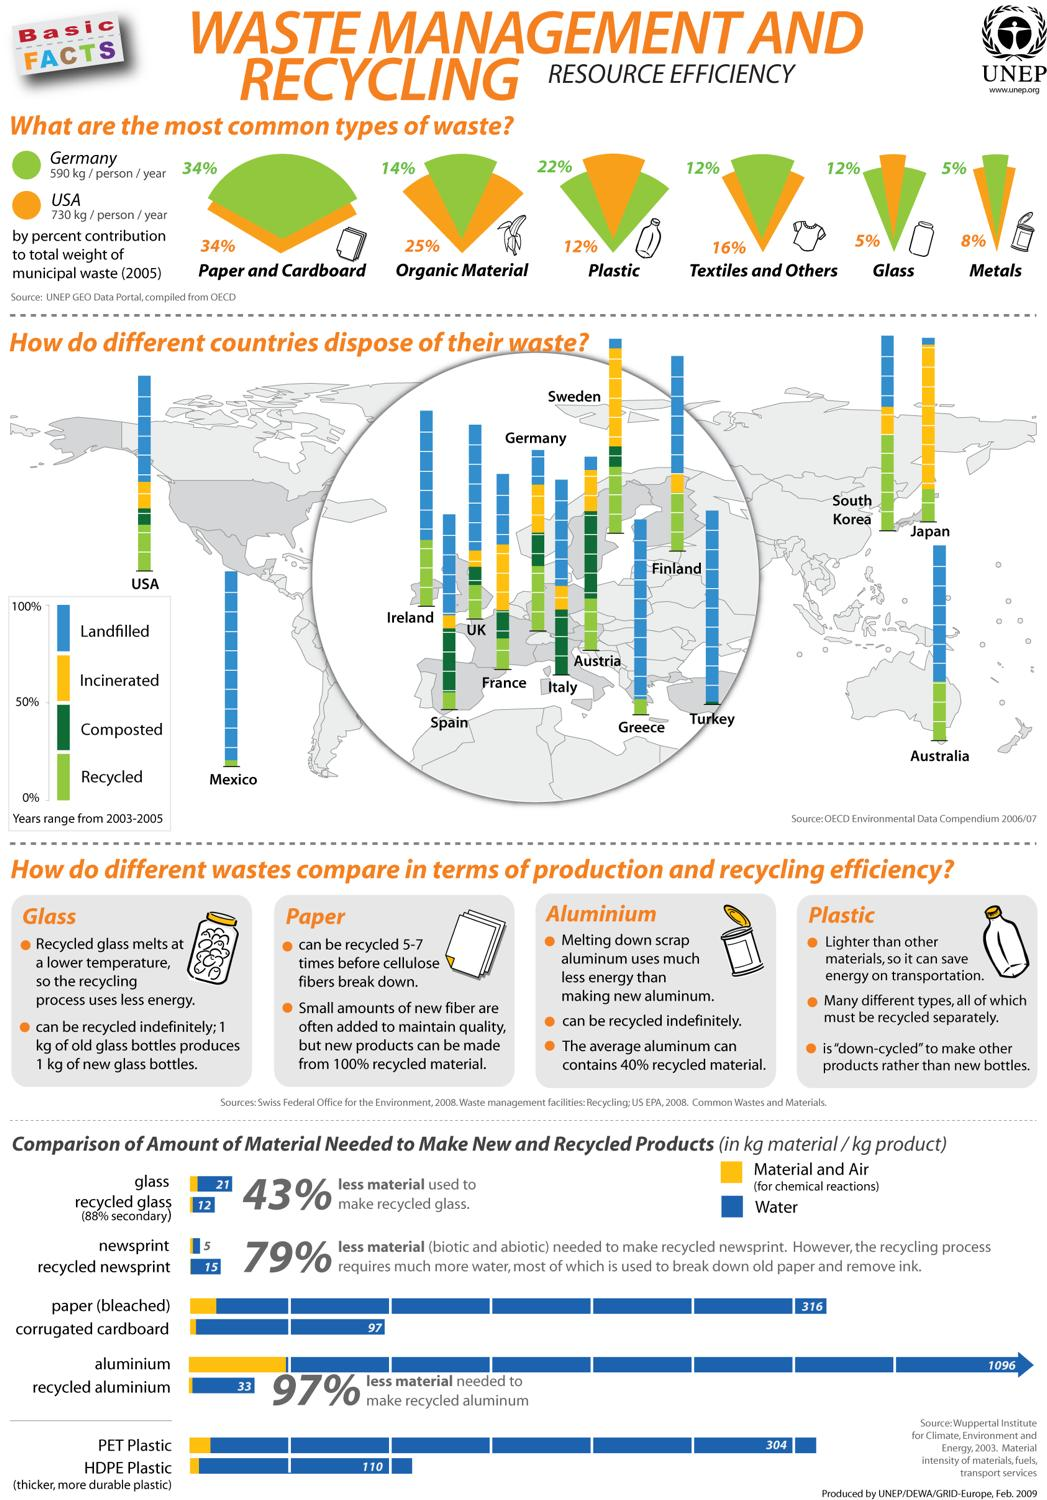Identify some key points in this picture. The United States generates more organic waste than Germany. Austria has the highest percentage of composted waste among all countries. The waste generated by the US and Germany consists of 34% paper and cardboard. According to recent estimates, textile and glass waste generated in Germany accounts for approximately 12% of the total waste generated in the country. Japan has the least amount of landfilled waste among all countries. 